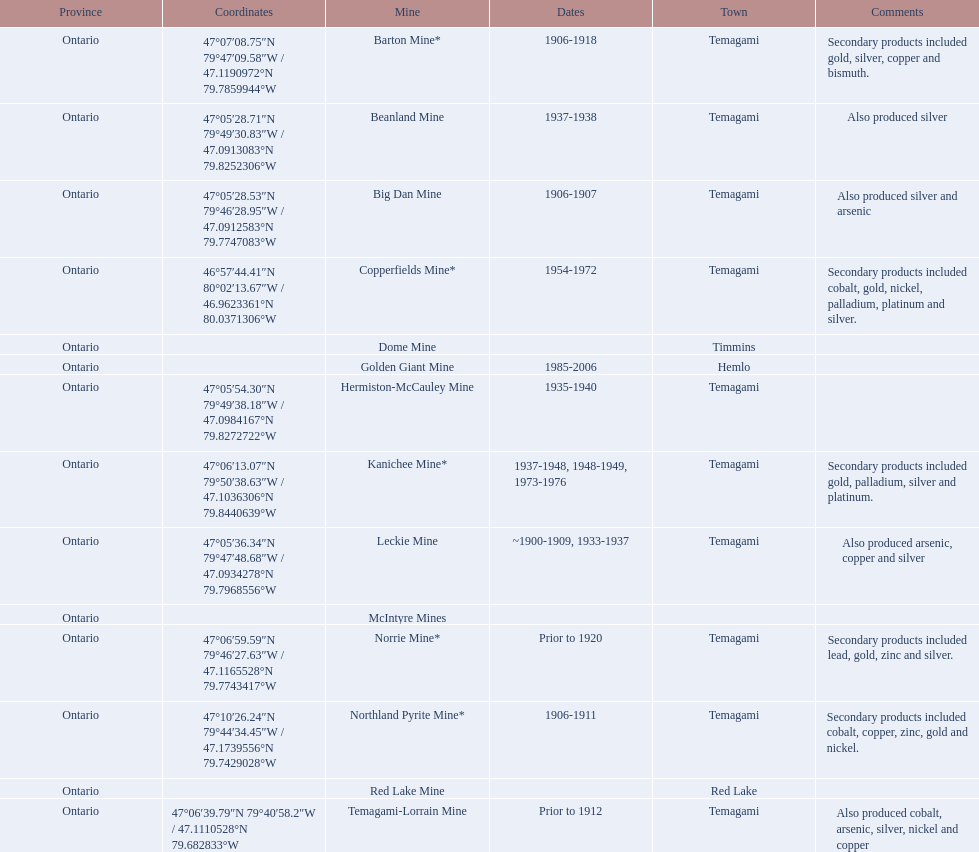What are all the mines with dates listed? Barton Mine*, Beanland Mine, Big Dan Mine, Copperfields Mine*, Golden Giant Mine, Hermiston-McCauley Mine, Kanichee Mine*, Leckie Mine, Norrie Mine*, Northland Pyrite Mine*, Temagami-Lorrain Mine. Which of those dates include the year that the mine was closed? 1906-1918, 1937-1938, 1906-1907, 1954-1972, 1985-2006, 1935-1940, 1937-1948, 1948-1949, 1973-1976, ~1900-1909, 1933-1937, 1906-1911. Which of those mines were opened the longest? Golden Giant Mine. 